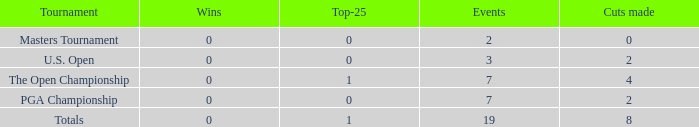What is the lowest Top-25 that has 3 Events and Wins greater than 0? None. 